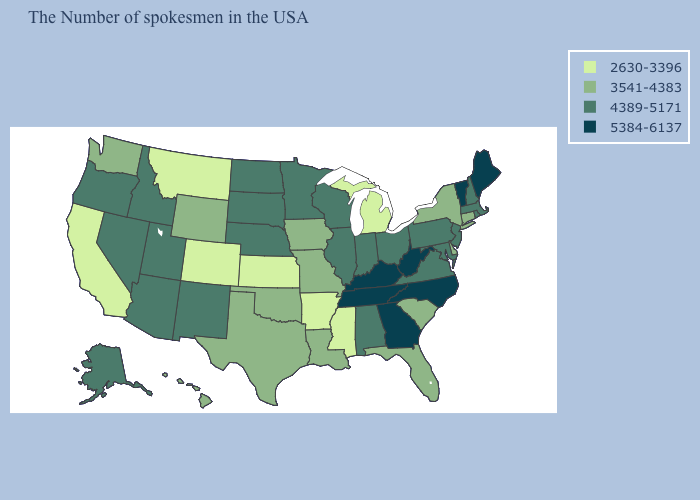Which states have the lowest value in the USA?
Keep it brief. Michigan, Mississippi, Arkansas, Kansas, Colorado, Montana, California. Does Vermont have the highest value in the USA?
Write a very short answer. Yes. Name the states that have a value in the range 3541-4383?
Give a very brief answer. Connecticut, New York, Delaware, South Carolina, Florida, Louisiana, Missouri, Iowa, Oklahoma, Texas, Wyoming, Washington, Hawaii. What is the highest value in the USA?
Keep it brief. 5384-6137. What is the lowest value in the USA?
Short answer required. 2630-3396. Does Arkansas have a lower value than Connecticut?
Quick response, please. Yes. Among the states that border South Dakota , which have the highest value?
Short answer required. Minnesota, Nebraska, North Dakota. Does Iowa have the highest value in the MidWest?
Write a very short answer. No. Name the states that have a value in the range 2630-3396?
Quick response, please. Michigan, Mississippi, Arkansas, Kansas, Colorado, Montana, California. Name the states that have a value in the range 3541-4383?
Be succinct. Connecticut, New York, Delaware, South Carolina, Florida, Louisiana, Missouri, Iowa, Oklahoma, Texas, Wyoming, Washington, Hawaii. What is the lowest value in states that border Iowa?
Give a very brief answer. 3541-4383. Does Arkansas have the highest value in the South?
Short answer required. No. Does the map have missing data?
Write a very short answer. No. Does Nevada have the lowest value in the West?
Short answer required. No. Which states have the lowest value in the USA?
Write a very short answer. Michigan, Mississippi, Arkansas, Kansas, Colorado, Montana, California. 